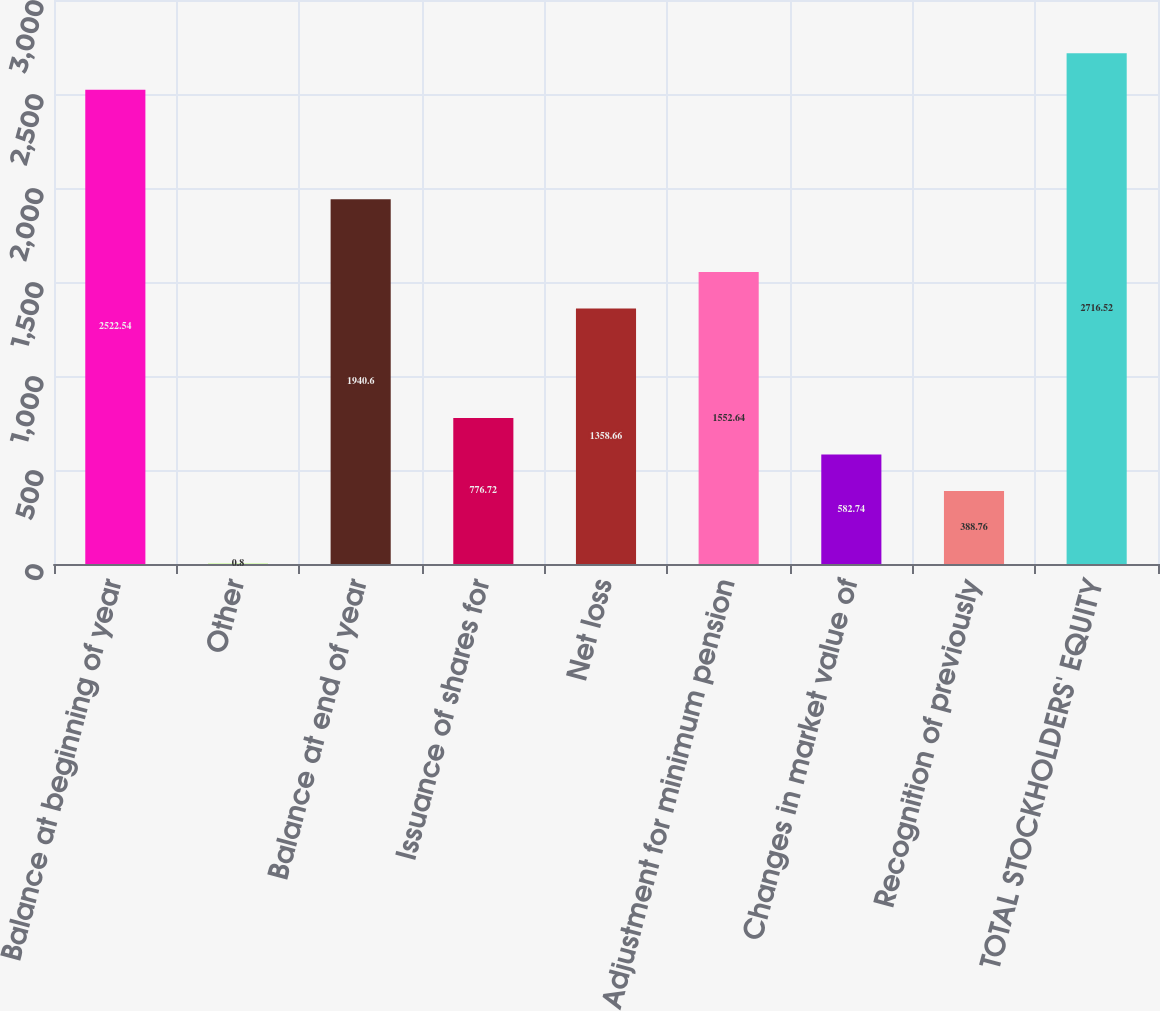Convert chart. <chart><loc_0><loc_0><loc_500><loc_500><bar_chart><fcel>Balance at beginning of year<fcel>Other<fcel>Balance at end of year<fcel>Issuance of shares for<fcel>Net loss<fcel>Adjustment for minimum pension<fcel>Changes in market value of<fcel>Recognition of previously<fcel>TOTAL STOCKHOLDERS' EQUITY<nl><fcel>2522.54<fcel>0.8<fcel>1940.6<fcel>776.72<fcel>1358.66<fcel>1552.64<fcel>582.74<fcel>388.76<fcel>2716.52<nl></chart> 